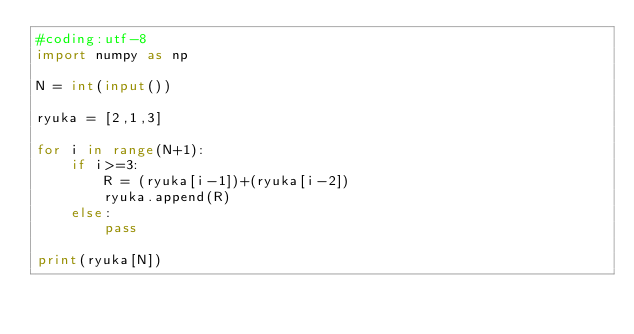<code> <loc_0><loc_0><loc_500><loc_500><_Python_>#coding:utf-8
import numpy as np

N = int(input())

ryuka = [2,1,3]

for i in range(N+1):
	if i>=3:
		R = (ryuka[i-1])+(ryuka[i-2])
		ryuka.append(R)
	else:
		pass

print(ryuka[N])</code> 